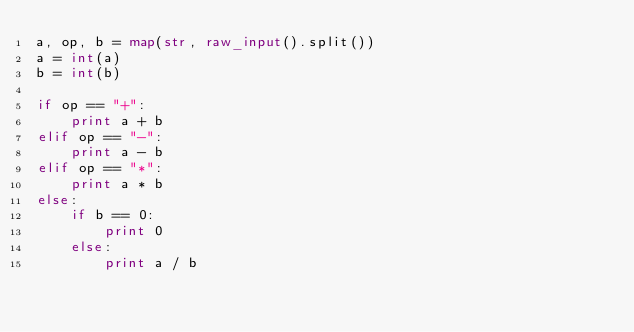<code> <loc_0><loc_0><loc_500><loc_500><_Python_>a, op, b = map(str, raw_input().split())
a = int(a)
b = int(b)

if op == "+":
	print a + b
elif op == "-":
	print a - b
elif op == "*":
	print a * b
else:
	if b == 0:
		print 0
	else:
		print a / b
	</code> 